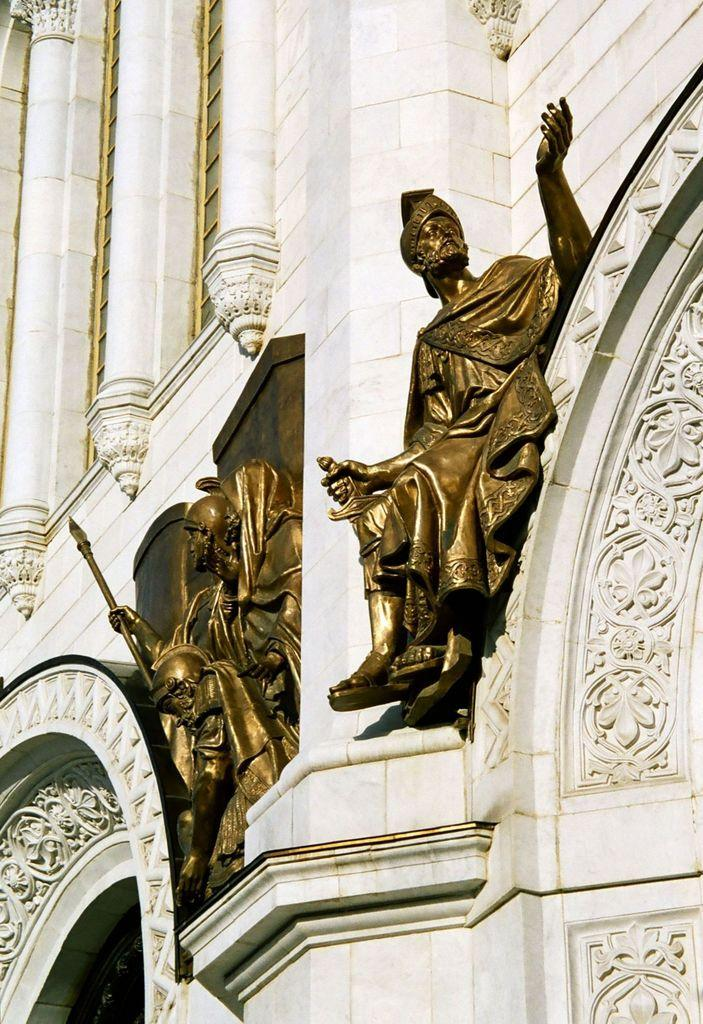What is the main subject of the image? The main subject of the image is a building. Are there any specific features on the building? Yes, there are statues on the building. How many kitties can be seen playing with the statues on the building? There are no kitties present in the image, and therefore no such activity can be observed. 